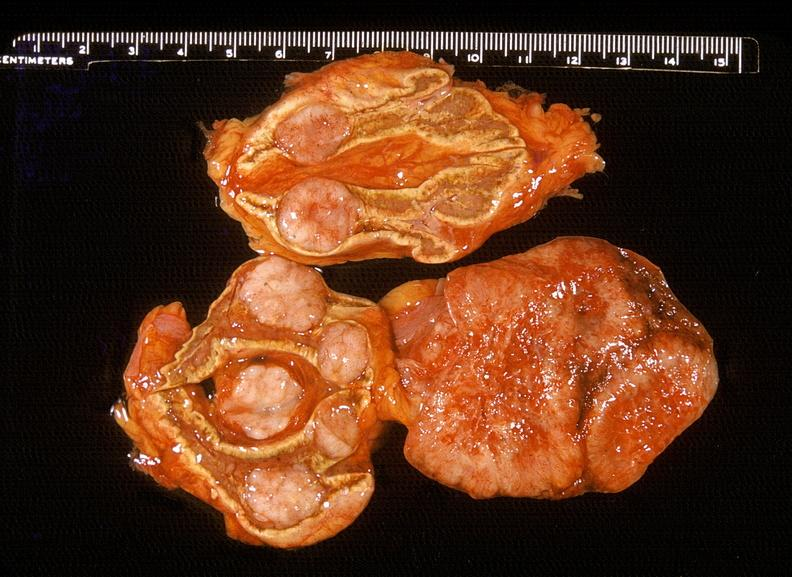does this image show adrenal, metastatic lung carcinoma?
Answer the question using a single word or phrase. Yes 